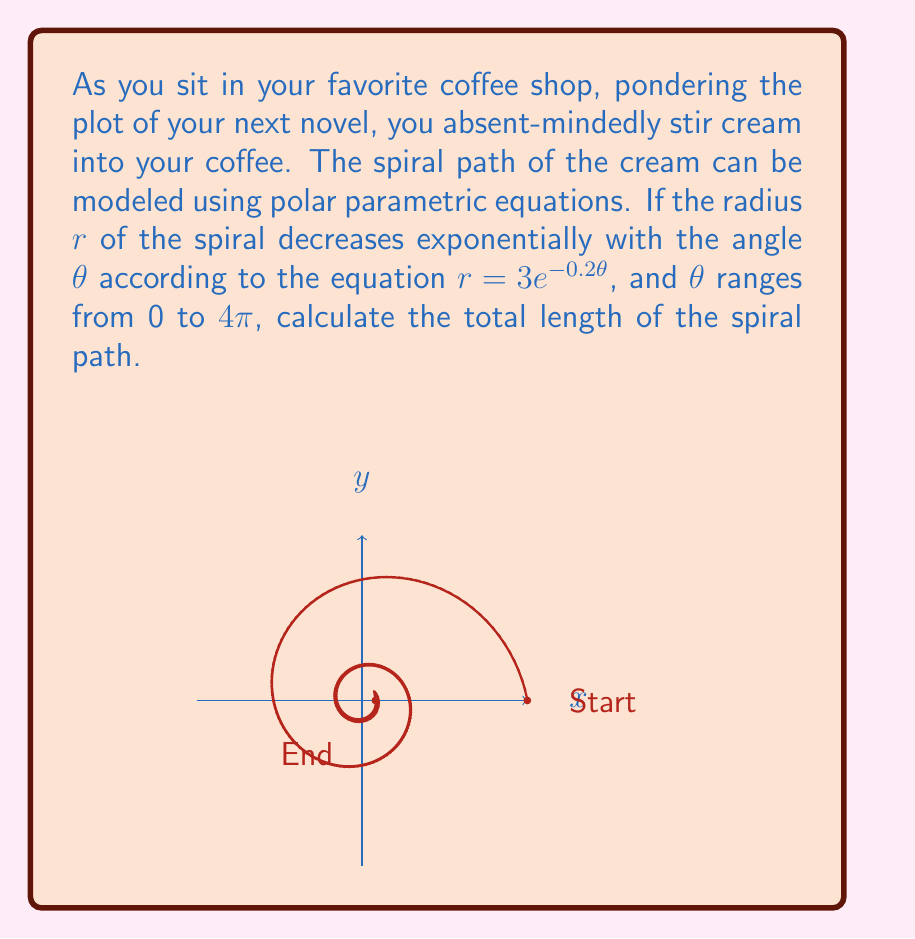Show me your answer to this math problem. To solve this problem, we'll follow these steps:

1) The parametric equations for the spiral in polar form are:
   $x = r\cos\theta = 3e^{-0.2\theta}\cos\theta$
   $y = r\sin\theta = 3e^{-0.2\theta}\sin\theta$

2) The formula for the length of a parametric curve is:
   $L = \int_a^b \sqrt{(\frac{dx}{d\theta})^2 + (\frac{dy}{d\theta})^2} d\theta$

3) We need to calculate $\frac{dx}{d\theta}$ and $\frac{dy}{d\theta}$:

   $\frac{dx}{d\theta} = 3e^{-0.2\theta}(-0.2\cos\theta) + 3e^{-0.2\theta}(-\sin\theta)$
                       $= -3e^{-0.2\theta}(0.2\cos\theta + \sin\theta)$

   $\frac{dy}{d\theta} = 3e^{-0.2\theta}(-0.2\sin\theta) + 3e^{-0.2\theta}(\cos\theta)$
                       $= 3e^{-0.2\theta}(\cos\theta - 0.2\sin\theta)$

4) Substituting these into the length formula:

   $L = \int_0^{4\pi} \sqrt{(3e^{-0.2\theta}(0.2\cos\theta + \sin\theta))^2 + (3e^{-0.2\theta}(\cos\theta - 0.2\sin\theta))^2} d\theta$

5) Simplifying under the square root:

   $L = \int_0^{4\pi} 3e^{-0.2\theta}\sqrt{(0.2\cos\theta + \sin\theta)^2 + (\cos\theta - 0.2\sin\theta)^2} d\theta$

6) Further simplification:

   $L = 3\int_0^{4\pi} e^{-0.2\theta}\sqrt{0.04\cos^2\theta + 0.4\cos\theta\sin\theta + \sin^2\theta + \cos^2\theta - 0.4\cos\theta\sin\theta + 0.04\sin^2\theta} d\theta$

   $L = 3\int_0^{4\pi} e^{-0.2\theta}\sqrt{1.04(\cos^2\theta + \sin^2\theta)} d\theta$

   $L = 3\int_0^{4\pi} e^{-0.2\theta}\sqrt{1.04} d\theta$

   $L = 3\sqrt{1.04}\int_0^{4\pi} e^{-0.2\theta} d\theta$

7) Evaluating the integral:

   $L = 3\sqrt{1.04}[-5e^{-0.2\theta}]_0^{4\pi}$

   $L = 15\sqrt{1.04}(1 - e^{-0.8\pi})$

8) This evaluates to approximately 14.76 units.
Answer: $15\sqrt{1.04}(1 - e^{-0.8\pi}) \approx 14.76$ units 